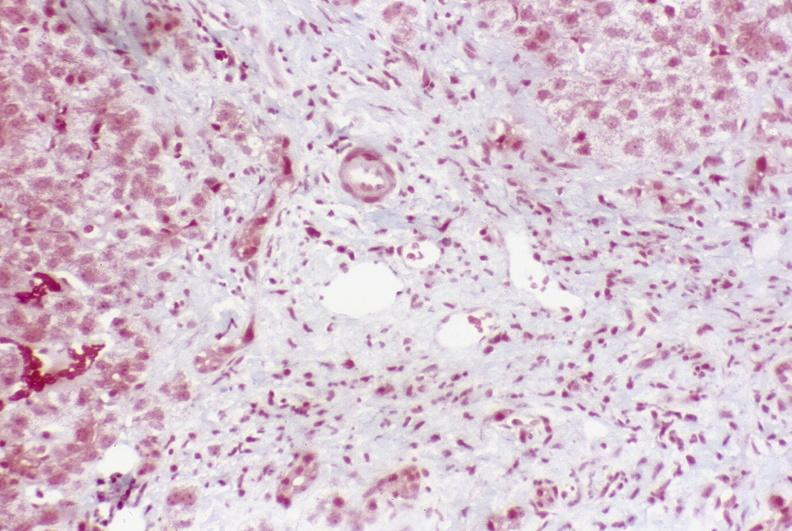does this image show primary sclerosing cholangitis?
Answer the question using a single word or phrase. Yes 